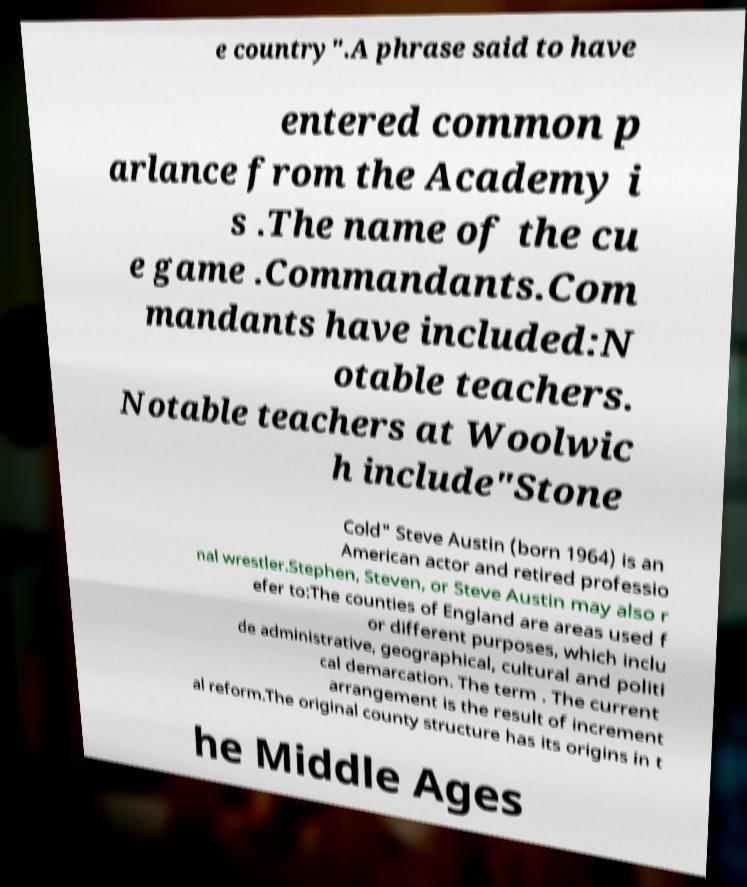Could you assist in decoding the text presented in this image and type it out clearly? e country".A phrase said to have entered common p arlance from the Academy i s .The name of the cu e game .Commandants.Com mandants have included:N otable teachers. Notable teachers at Woolwic h include"Stone Cold" Steve Austin (born 1964) is an American actor and retired professio nal wrestler.Stephen, Steven, or Steve Austin may also r efer to:The counties of England are areas used f or different purposes, which inclu de administrative, geographical, cultural and politi cal demarcation. The term . The current arrangement is the result of increment al reform.The original county structure has its origins in t he Middle Ages 